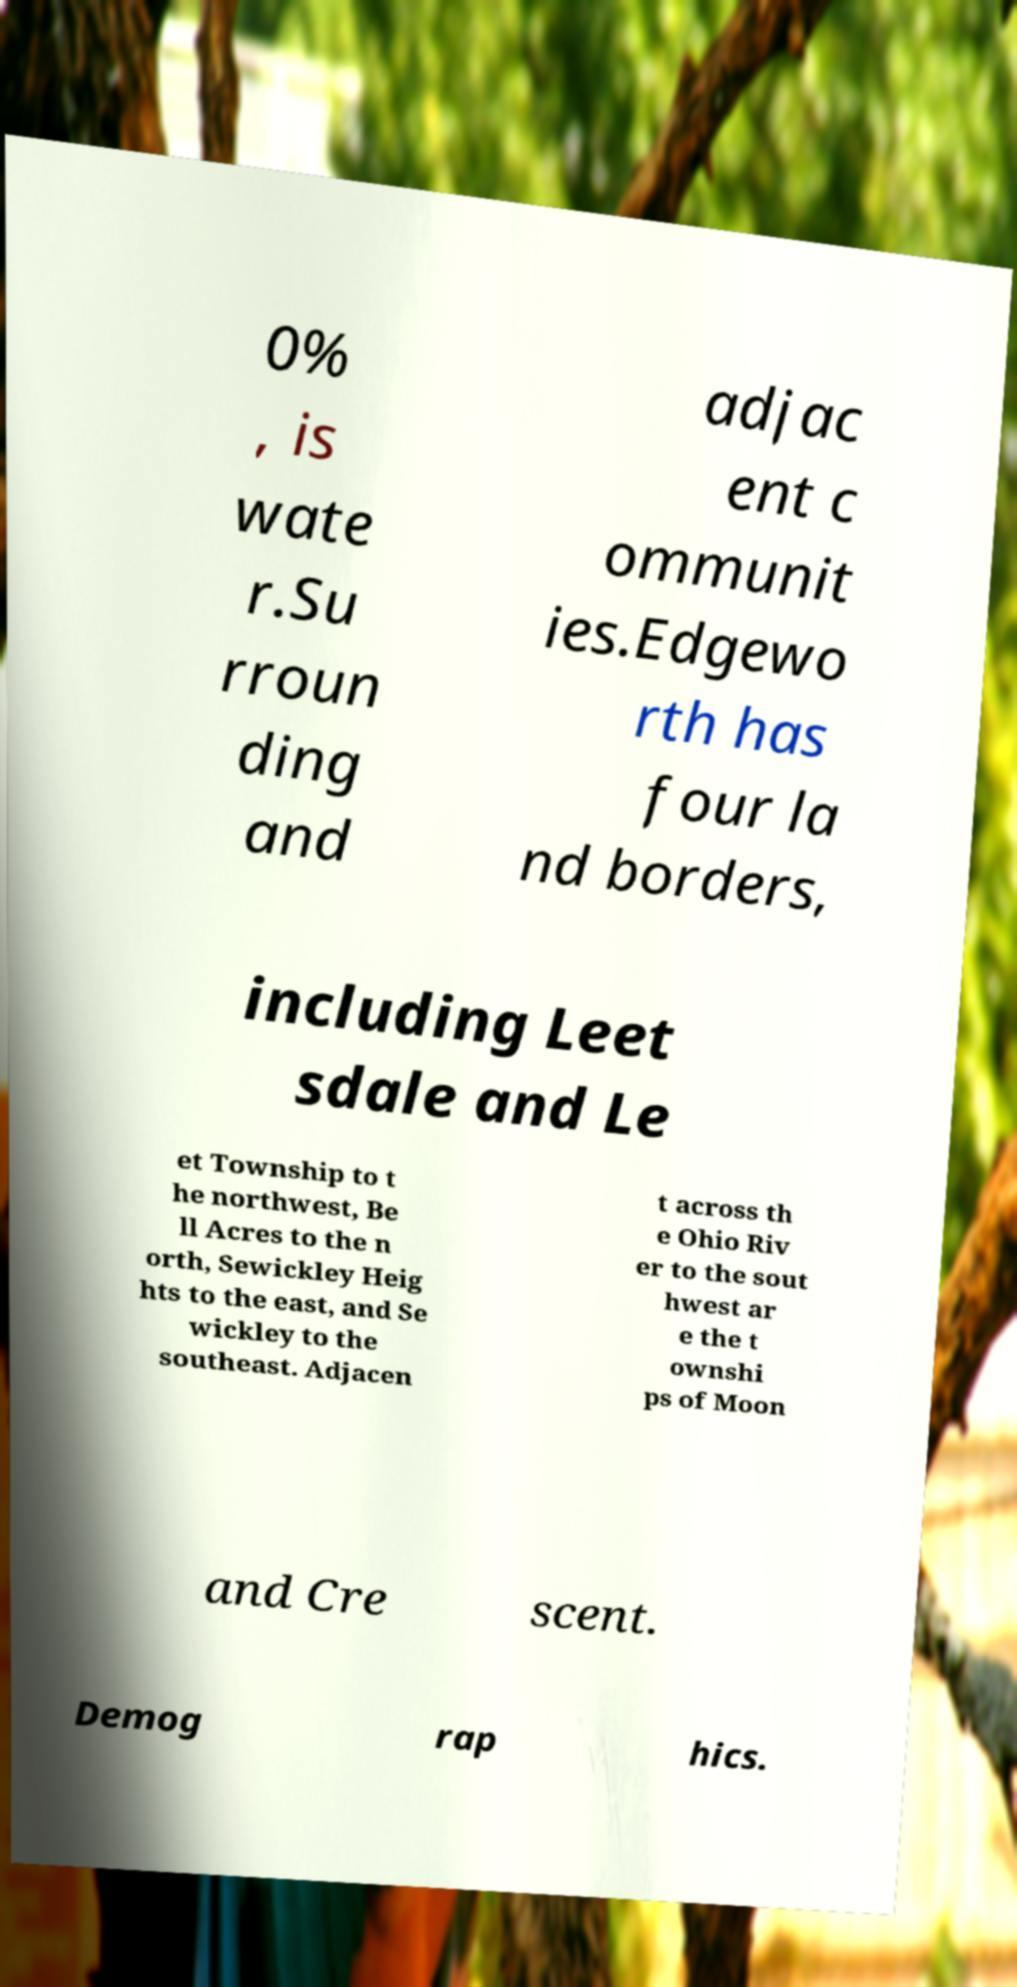Please identify and transcribe the text found in this image. 0% , is wate r.Su rroun ding and adjac ent c ommunit ies.Edgewo rth has four la nd borders, including Leet sdale and Le et Township to t he northwest, Be ll Acres to the n orth, Sewickley Heig hts to the east, and Se wickley to the southeast. Adjacen t across th e Ohio Riv er to the sout hwest ar e the t ownshi ps of Moon and Cre scent. Demog rap hics. 